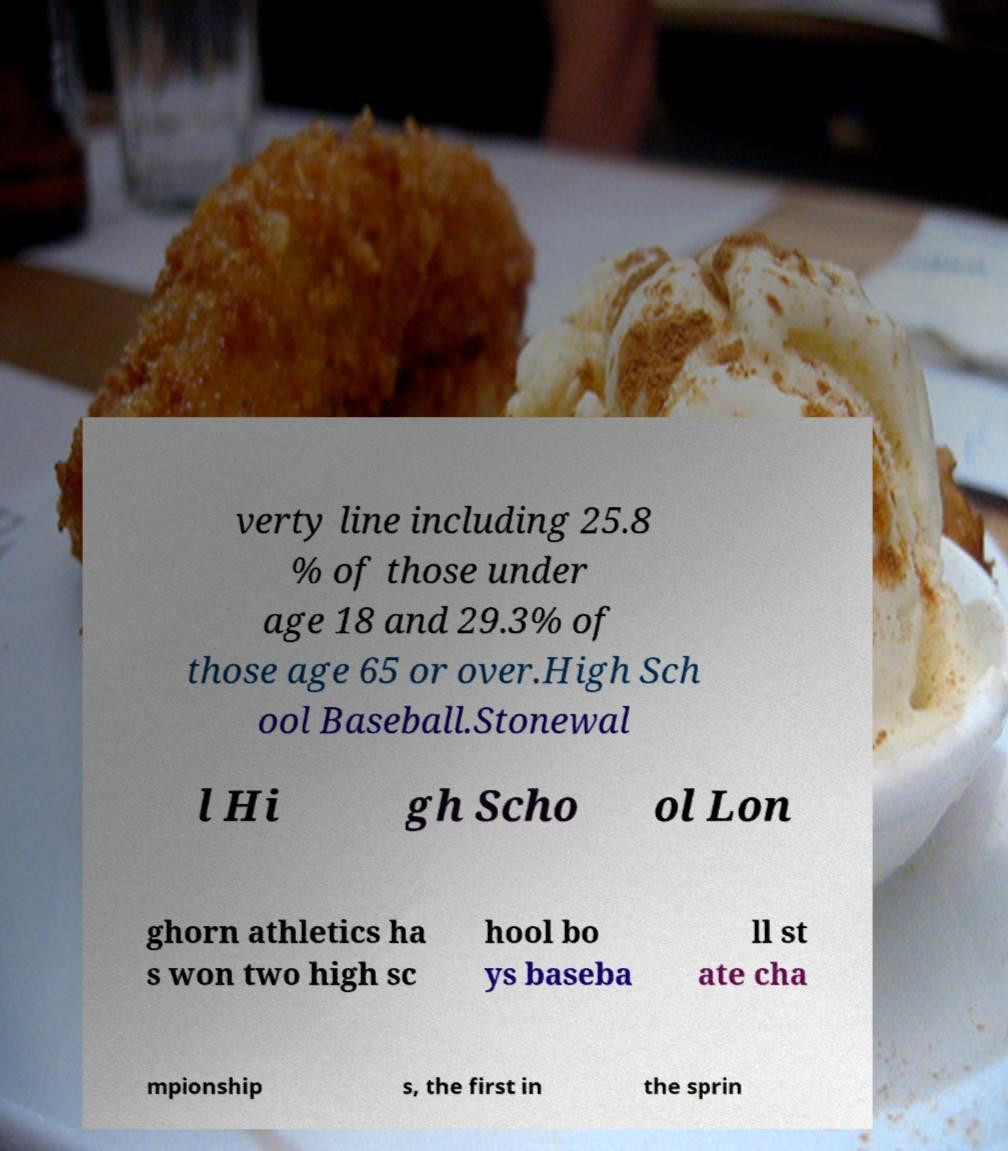Please identify and transcribe the text found in this image. verty line including 25.8 % of those under age 18 and 29.3% of those age 65 or over.High Sch ool Baseball.Stonewal l Hi gh Scho ol Lon ghorn athletics ha s won two high sc hool bo ys baseba ll st ate cha mpionship s, the first in the sprin 